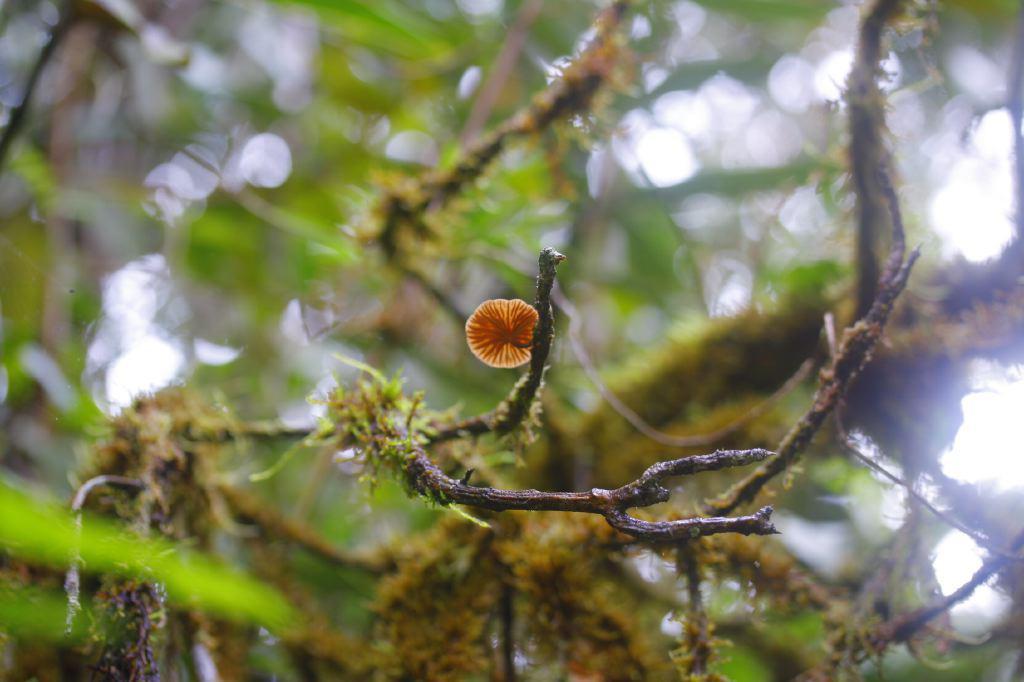Could you give a brief overview of what you see in this image? In this image there is a tree and we can see a flower. 